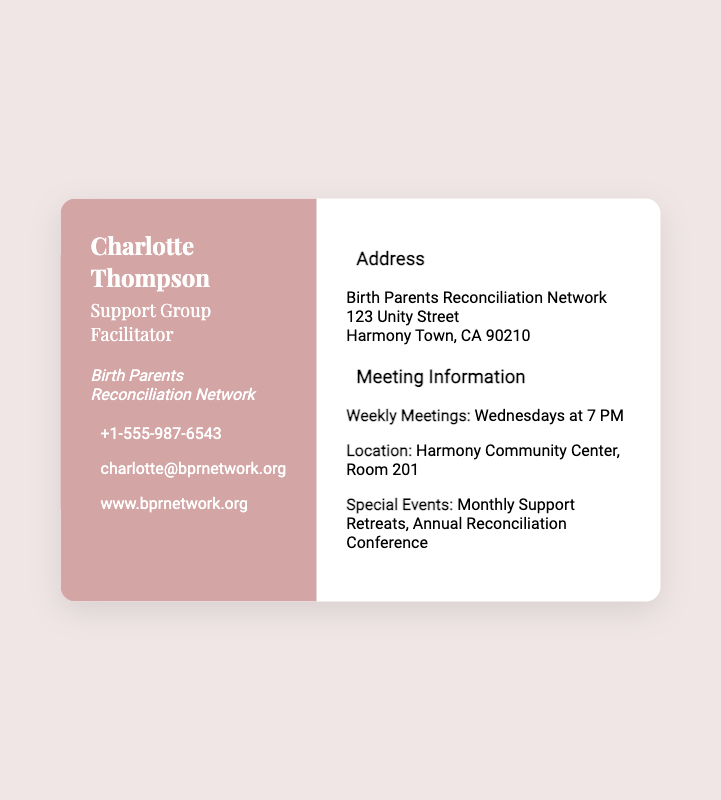what is the name of the facilitator? The facilitator's name is prominently displayed at the top of the document.
Answer: Charlotte Thompson what is the phone number for the Birth Parents Reconciliation Network? The phone number is listed under contact information in the left section of the card.
Answer: +1-555-987-6543 where are the weekly meetings held? The meeting location is mentioned in the right section under meeting information.
Answer: Harmony Community Center, Room 201 what day and time do the weekly meetings occur? The schedule for the weekly meetings is indicated in the meeting information.
Answer: Wednesdays at 7 PM what is the address of the Birth Parents Reconciliation Network? The address is displayed in the right section of the document.
Answer: 123 Unity Street, Harmony Town, CA 90210 how often do special events occur? Information about events and their frequency can be found in the meeting details.
Answer: Monthly what is the website for the Birth Parents Reconciliation Network? The website is included in the contact information section.
Answer: www.bprnetwork.org which social media platforms are linked on the card? The social media links are listed in the left section, identifying specific platforms.
Answer: Facebook, Twitter, Instagram what type of document is this? The overall structure and purpose of the information indicate it serves a specific function.
Answer: Business card 